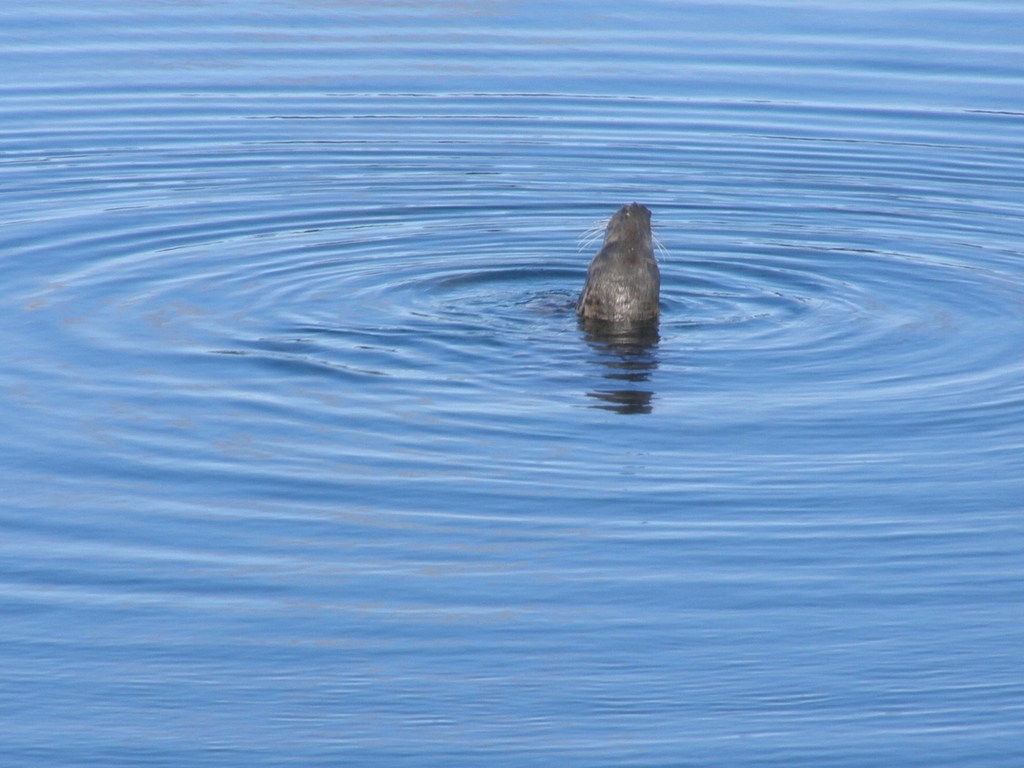What kind of animal is causing the ripples in the water? It appears to be a marine mammal, likely a seal or sea lion, given the shape of the head and the characteristic way it's poking out of the water, which is common behavior for these animals. 